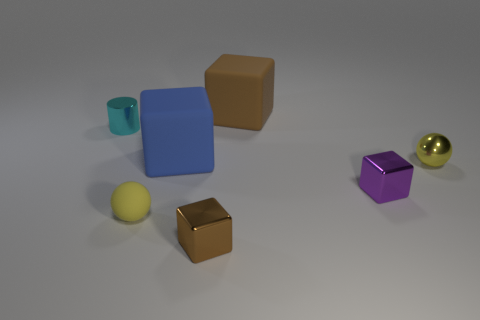Subtract 1 cubes. How many cubes are left? 3 Add 2 small brown metal cubes. How many objects exist? 9 Subtract all gray cubes. Subtract all yellow cylinders. How many cubes are left? 4 Subtract all cubes. How many objects are left? 3 Add 2 yellow metallic spheres. How many yellow metallic spheres are left? 3 Add 6 tiny yellow balls. How many tiny yellow balls exist? 8 Subtract 0 purple balls. How many objects are left? 7 Subtract all large yellow cubes. Subtract all metallic blocks. How many objects are left? 5 